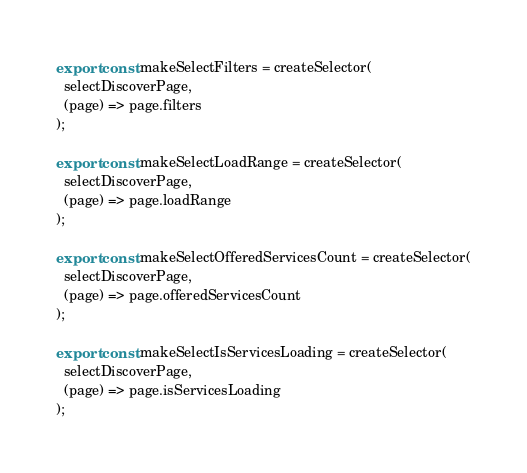Convert code to text. <code><loc_0><loc_0><loc_500><loc_500><_TypeScript_>export const makeSelectFilters = createSelector(
  selectDiscoverPage,
  (page) => page.filters
);

export const makeSelectLoadRange = createSelector(
  selectDiscoverPage,
  (page) => page.loadRange
);

export const makeSelectOfferedServicesCount = createSelector(
  selectDiscoverPage,
  (page) => page.offeredServicesCount
);

export const makeSelectIsServicesLoading = createSelector(
  selectDiscoverPage,
  (page) => page.isServicesLoading
);
</code> 